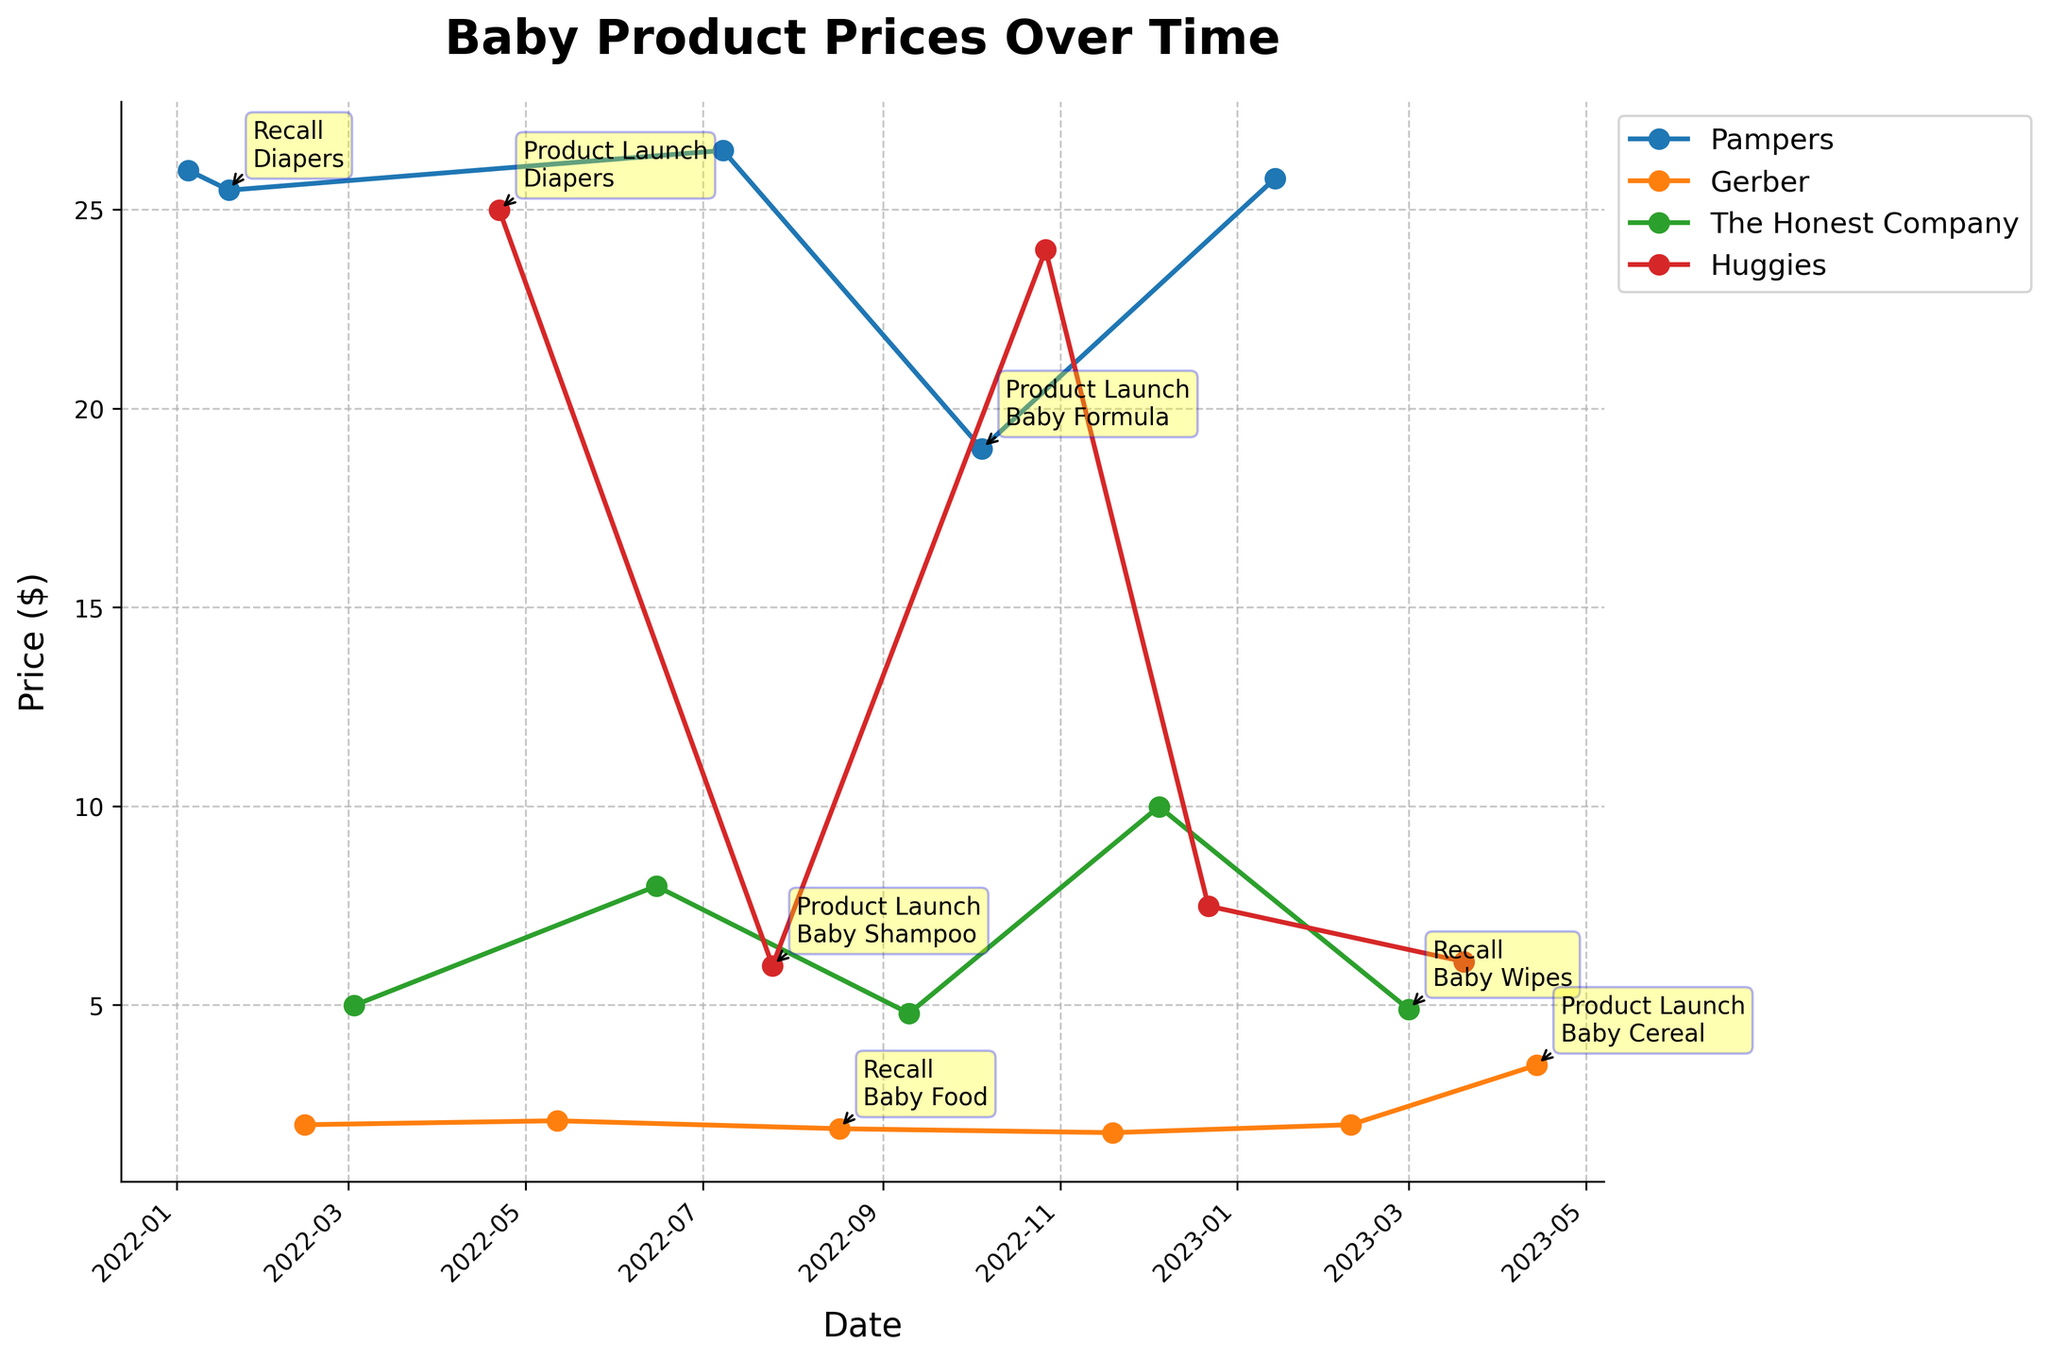How many different baby product brands are shown in the plot? The plot's legend or different colored lines represent different brands. Each unique color or label corresponds to a different brand.
Answer: 4 What is the highest price recorded for any baby product in the plot? By looking at the peak point among all brands on the y-axis, which represents the price, we can identify the highest price.
Answer: $26.49 Which brand had a product recall event and when did it happen? We see annotations indicating events. Look for any "Recall" and note the corresponding brand and date.
Answer: Pampers on 2022-01-19, Gerber on 2022-08-17, The Honest Company on 2023-03-01 On what date did Pampers launch a baby formula product, and what was its price then? Look for an annotation of "Product Launch" related to Pampers and check the corresponding date and price.
Answer: 2022-10-05, $18.99 Which month in 2022 had the highest number of product events for baby brands? Count the number of annotations in each month of 2022 and identify the month with the most events.
Answer: April (two events) Which brand had the highest average price over the entire period? For each brand, sum up all the recorded prices and divide by the number of price points, then compare the averages.
Answer: Pampers How did Gerber's Baby Food recall on 2022-08-17 affect its price afterward? Look at the price trend for Gerber's Baby Food before and after the recall date to see if there's a visible change.
Answer: Price decreased slightly Between Pampers and Huggies, which brand had more product launches shown? Count the annotations labeled "Product Launch" for each brand and compare the counts.
Answer: Huggies 